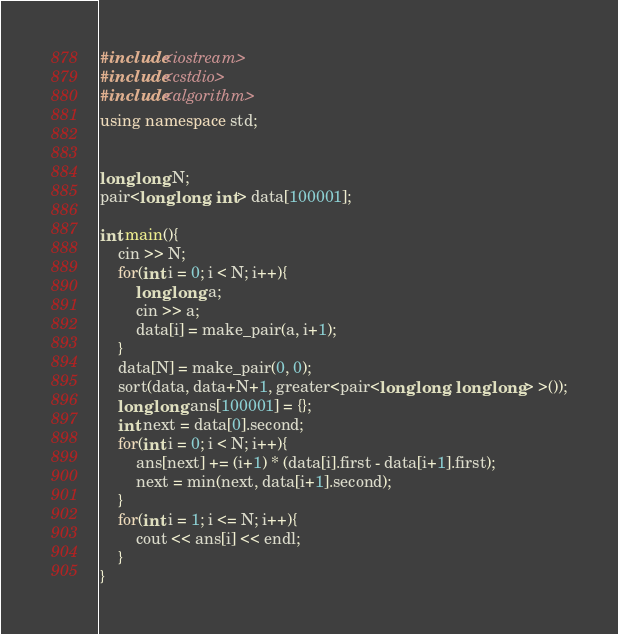Convert code to text. <code><loc_0><loc_0><loc_500><loc_500><_C++_>#include<iostream>
#include<cstdio>
#include<algorithm>
using namespace std;


long long N;
pair<long long, int> data[100001];

int main(){
    cin >> N;
    for(int i = 0; i < N; i++){
        long long a;
        cin >> a;
        data[i] = make_pair(a, i+1);
    }
    data[N] = make_pair(0, 0);
    sort(data, data+N+1, greater<pair<long long, long long> >());
    long long ans[100001] = {};
    int next = data[0].second;
    for(int i = 0; i < N; i++){
        ans[next] += (i+1) * (data[i].first - data[i+1].first);
        next = min(next, data[i+1].second);
    }
    for(int i = 1; i <= N; i++){
        cout << ans[i] << endl;
    }
}
</code> 